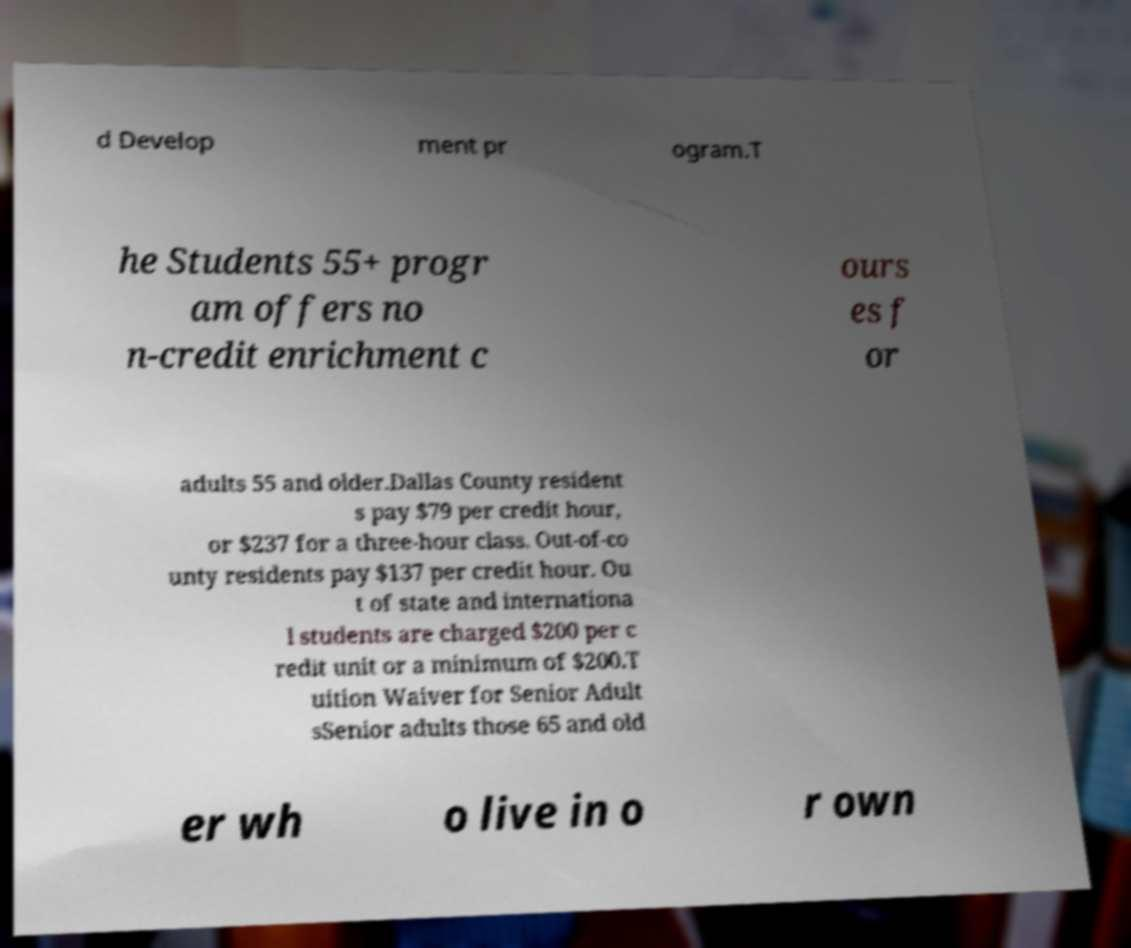For documentation purposes, I need the text within this image transcribed. Could you provide that? d Develop ment pr ogram.T he Students 55+ progr am offers no n-credit enrichment c ours es f or adults 55 and older.Dallas County resident s pay $79 per credit hour, or $237 for a three-hour class. Out-of-co unty residents pay $137 per credit hour. Ou t of state and internationa l students are charged $200 per c redit unit or a minimum of $200.T uition Waiver for Senior Adult sSenior adults those 65 and old er wh o live in o r own 